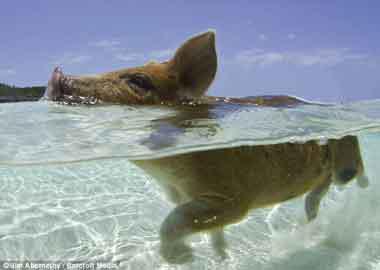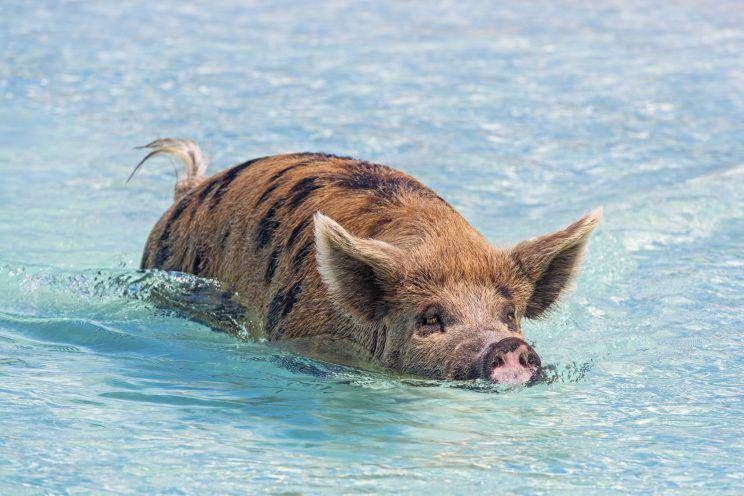The first image is the image on the left, the second image is the image on the right. Considering the images on both sides, is "The right image contains exactly one spotted pig, which is viewed from above and swimming toward the camera." valid? Answer yes or no. Yes. The first image is the image on the left, the second image is the image on the right. Given the left and right images, does the statement "There is one pig in the right image." hold true? Answer yes or no. Yes. 